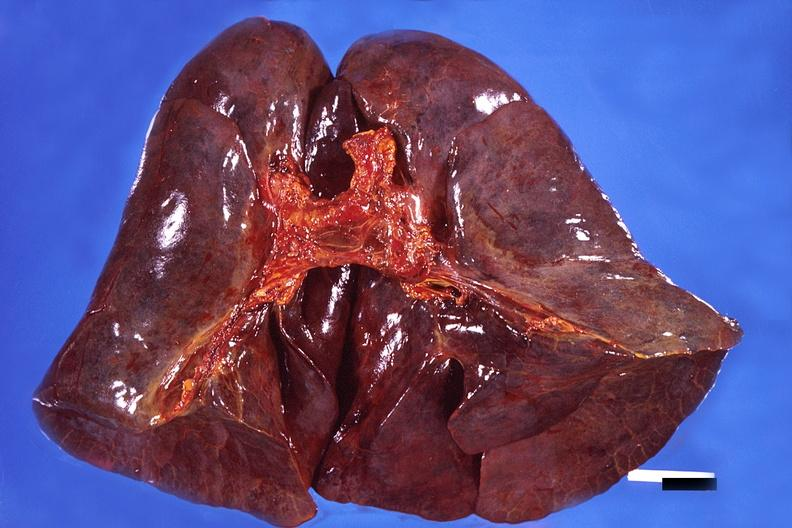does this image show lung, hemorrhagic bronchopneumonia, wilson 's disease?
Answer the question using a single word or phrase. Yes 